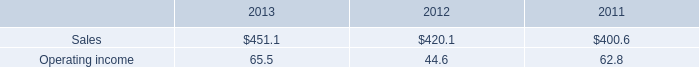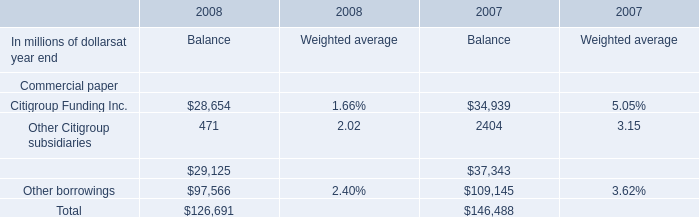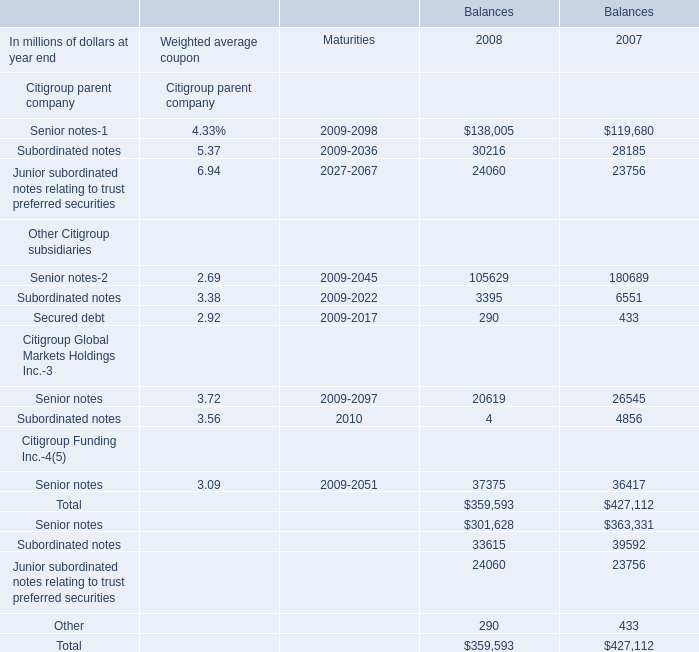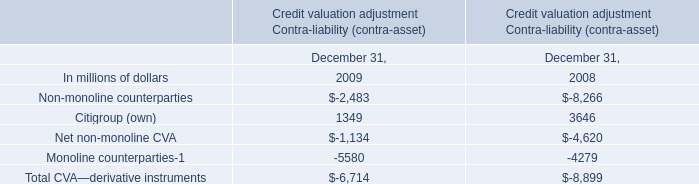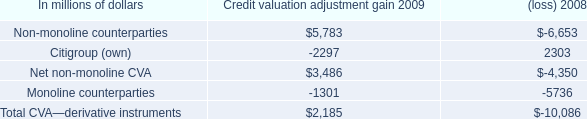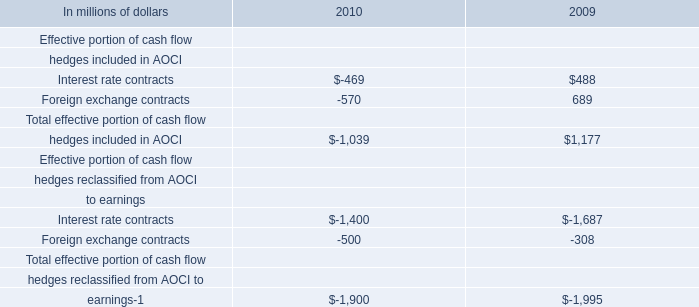What is the growing rate of Other borrowings in the years with the least Citigroup Funding Inc for Balance? (in million) 
Computations: ((97566 - 109145) / 109145)
Answer: -0.10609. 